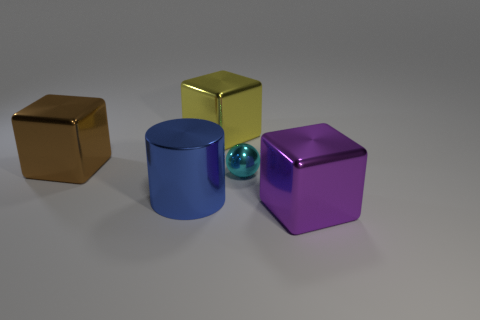Add 1 blue things. How many objects exist? 6 Subtract all cubes. How many objects are left? 2 Subtract 0 yellow cylinders. How many objects are left? 5 Subtract all brown cubes. Subtract all tiny balls. How many objects are left? 3 Add 5 large brown blocks. How many large brown blocks are left? 6 Add 5 big gray objects. How many big gray objects exist? 5 